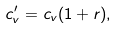Convert formula to latex. <formula><loc_0><loc_0><loc_500><loc_500>c _ { v } ^ { \prime } = c _ { v } ( 1 + r ) ,</formula> 